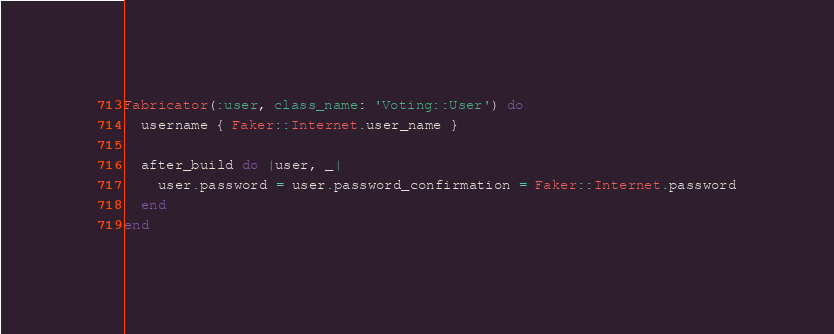Convert code to text. <code><loc_0><loc_0><loc_500><loc_500><_Ruby_>Fabricator(:user, class_name: 'Voting::User') do
  username { Faker::Internet.user_name }

  after_build do |user, _|
    user.password = user.password_confirmation = Faker::Internet.password
  end
end
</code> 